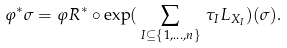<formula> <loc_0><loc_0><loc_500><loc_500>\varphi ^ { * } \sigma = \varphi _ { \real } R ^ { * } \circ \exp ( \, \sum _ { I \subseteq \{ 1 , \dots , n \} } \, \tau _ { I } L _ { X _ { I } } ) ( \sigma ) .</formula> 